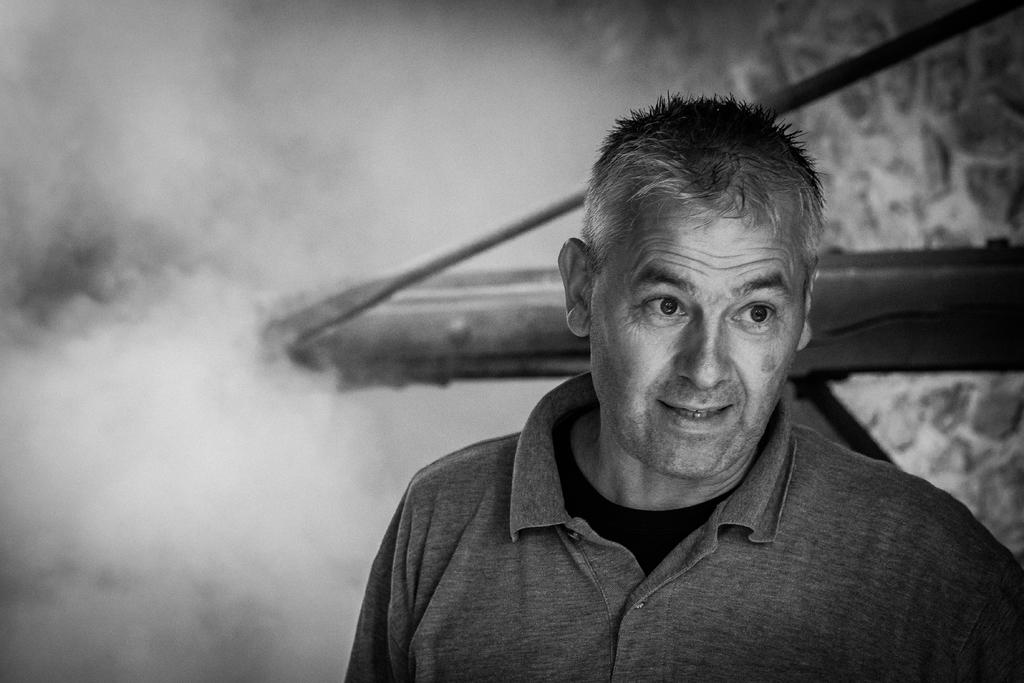What is the main subject of the image? There is a person standing in the center of the image. Can you describe the person's facial expression? The person has an expression on their face. What can be seen in the background of the image? There is some smoke and a wooden stand in the background of the image. What type of prose is being recited by the person in the image? There is no indication in the image that the person is reciting any prose. Can you describe the texture of the mist in the image? There is no mist present in the image; it features smoke in the background. 